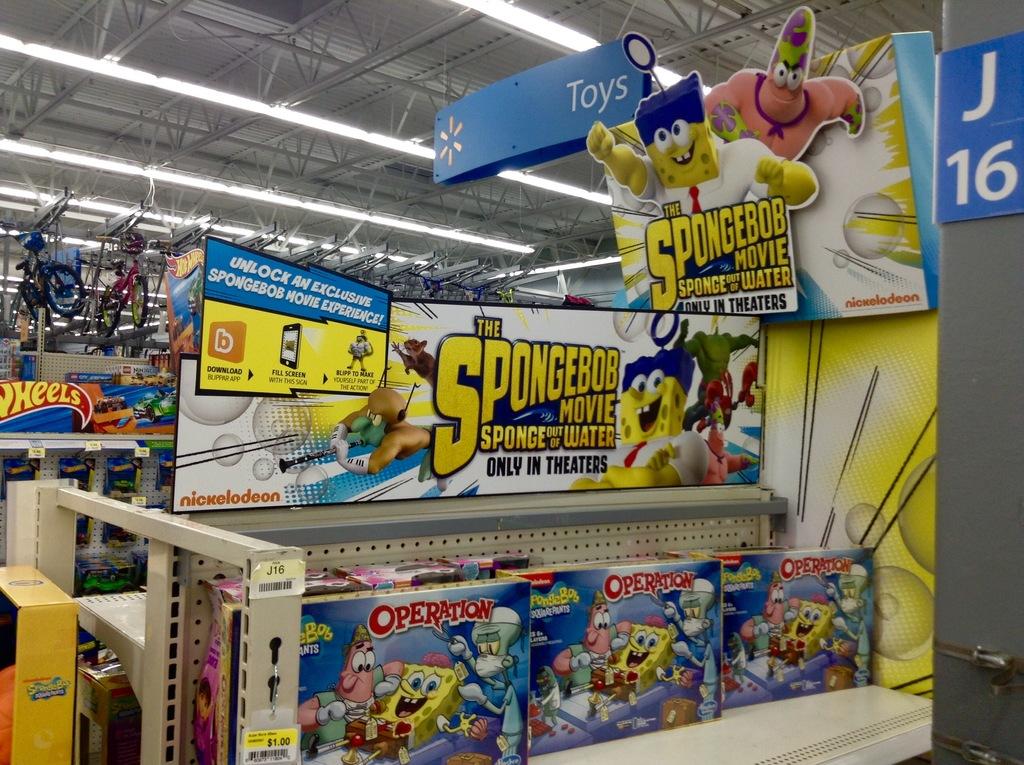What movie is being advertised?
Provide a succinct answer. Spongebob. What aisle number is this?
Give a very brief answer. J16. 